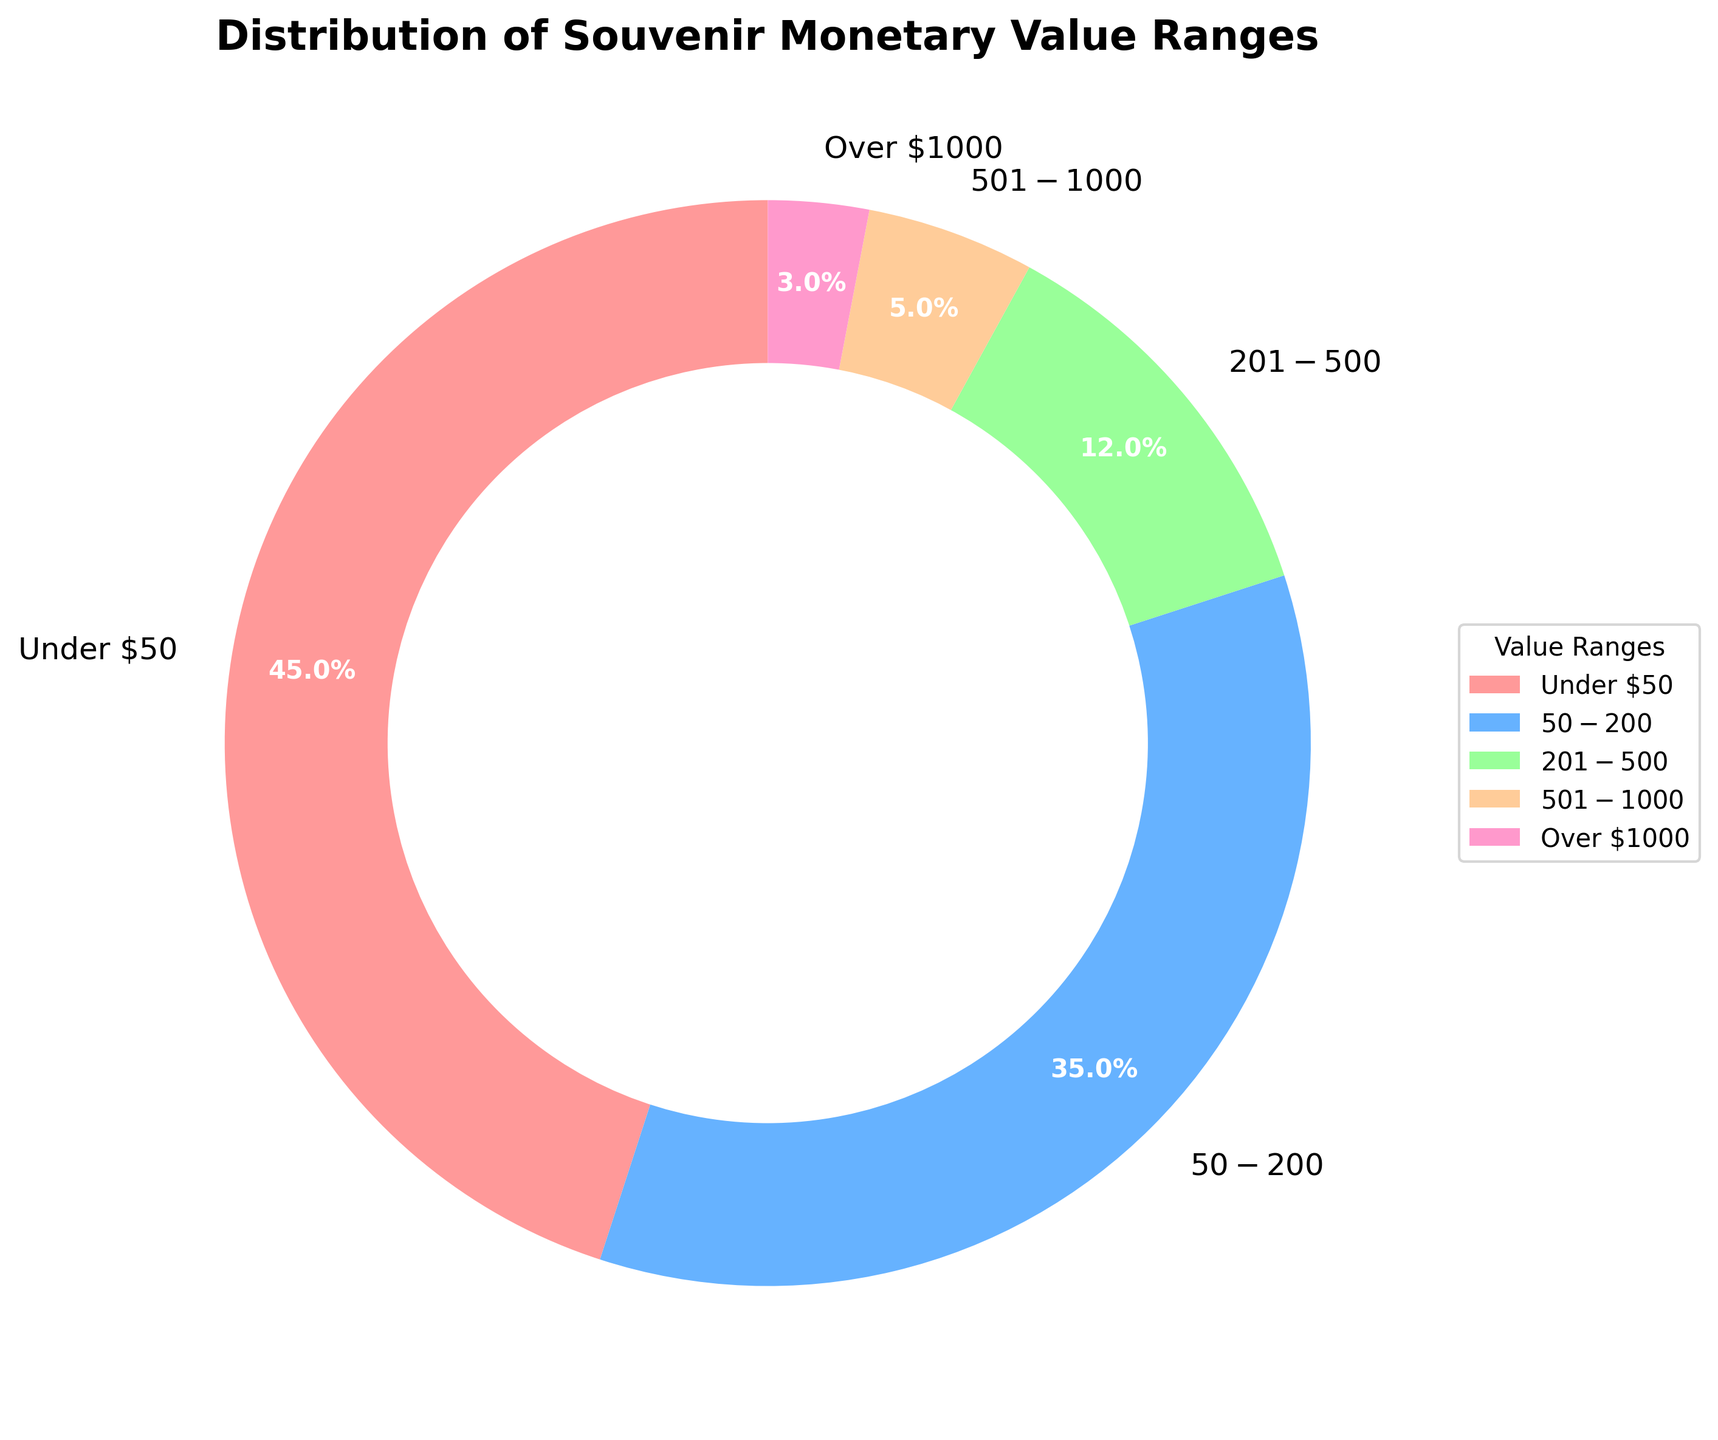What percentage of souvenirs are valued under $50? The pie chart segment labeled "Under $50" has a value of 45%.
Answer: 45% Which value range has the smallest percentage of souvenirs? The pie chart shows that the segment labeled "Over $1000" is the smallest, with a value of 3%.
Answer: Over $1000 How many value ranges have a percentage greater than 10%? The segments labeled "Under $50" (45%), "$50-$200" (35%), and "$201-$500" (12%) have percentages greater than 10%. There are three such segments.
Answer: 3 Is the percentage of souvenirs valued under $50 greater than the combined percentage of souvenirs valued in the $501-$1000 and Over $1000 ranges? The percentage for "Under $50" is 45%. The combined percentage for "$501-$1000" (5%) and "Over $1000" (3%) is 8%. 45% is greater than 8%.
Answer: Yes What is the difference in percentage between the $50-$200 range and the $201-$500 range? The percentage for "$50-$200" is 35% and for "$201-$500" is 12%. The difference is 35% - 12% = 23%.
Answer: 23% Which value range has the second highest percentage? The pie chart shows the second highest percentage is the "$50-$200" range with 35%.
Answer: $50-$200 What is the combined percentage of souvenirs valued between $50 and $500? The segments labeled "$50-$200" and "$201-$500" have values of 35% and 12%. Their combined percentage is 35% + 12% = 47%.
Answer: 47% How does the percentage of souvenirs in the $201-$500 range compare to those in the $501-$1000 range? The pie chart shows that the "$201-$500" range has 12%, while the "$501-$1000" range has 5%. 12% is greater than 5%.
Answer: $201-$500 has a greater percentage What color represents the $50-$200 range in the pie chart? The pie chart uses custom colors and the segment for "$50-$200" is shown in blue.
Answer: Blue 